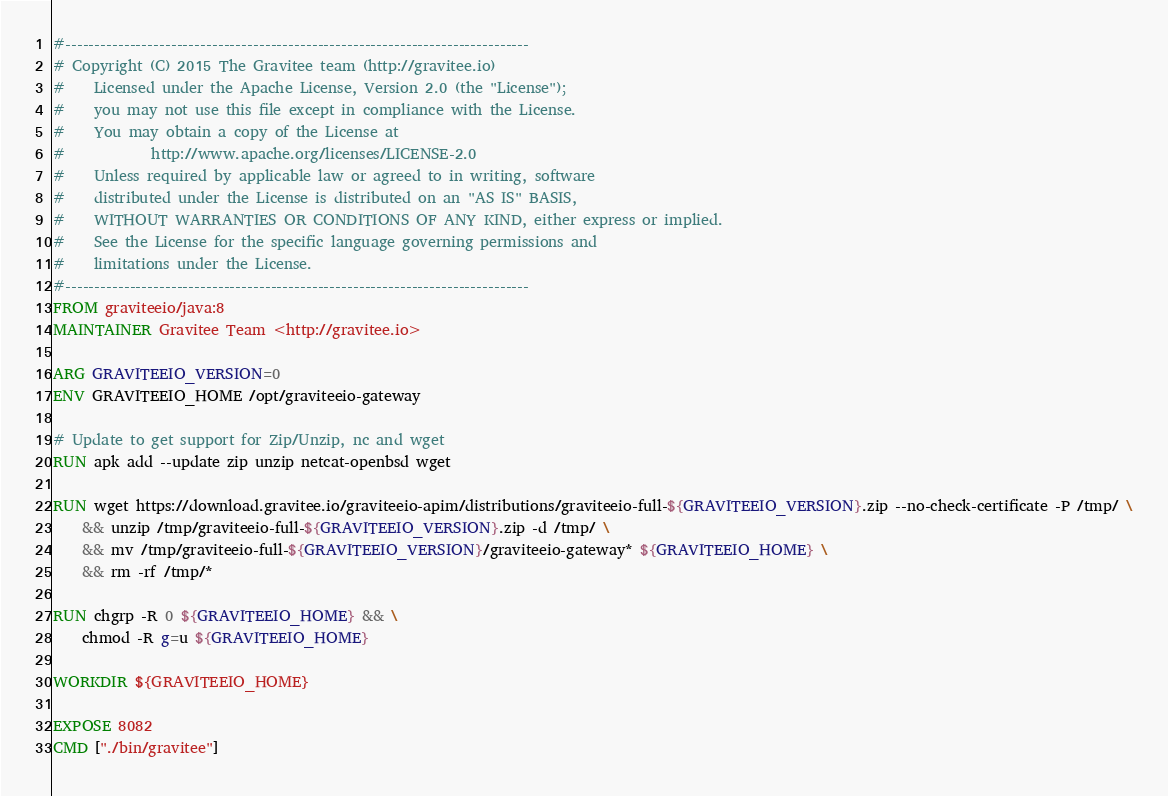Convert code to text. <code><loc_0><loc_0><loc_500><loc_500><_Dockerfile_>#-------------------------------------------------------------------------------
# Copyright (C) 2015 The Gravitee team (http://gravitee.io)
#    Licensed under the Apache License, Version 2.0 (the "License");
#    you may not use this file except in compliance with the License.
#    You may obtain a copy of the License at
#            http://www.apache.org/licenses/LICENSE-2.0
#    Unless required by applicable law or agreed to in writing, software
#    distributed under the License is distributed on an "AS IS" BASIS,
#    WITHOUT WARRANTIES OR CONDITIONS OF ANY KIND, either express or implied.
#    See the License for the specific language governing permissions and
#    limitations under the License.
#-------------------------------------------------------------------------------
FROM graviteeio/java:8
MAINTAINER Gravitee Team <http://gravitee.io>

ARG GRAVITEEIO_VERSION=0
ENV GRAVITEEIO_HOME /opt/graviteeio-gateway

# Update to get support for Zip/Unzip, nc and wget
RUN apk add --update zip unzip netcat-openbsd wget

RUN wget https://download.gravitee.io/graviteeio-apim/distributions/graviteeio-full-${GRAVITEEIO_VERSION}.zip --no-check-certificate -P /tmp/ \
    && unzip /tmp/graviteeio-full-${GRAVITEEIO_VERSION}.zip -d /tmp/ \
    && mv /tmp/graviteeio-full-${GRAVITEEIO_VERSION}/graviteeio-gateway* ${GRAVITEEIO_HOME} \
    && rm -rf /tmp/*

RUN chgrp -R 0 ${GRAVITEEIO_HOME} && \
    chmod -R g=u ${GRAVITEEIO_HOME}

WORKDIR ${GRAVITEEIO_HOME}

EXPOSE 8082
CMD ["./bin/gravitee"]
</code> 